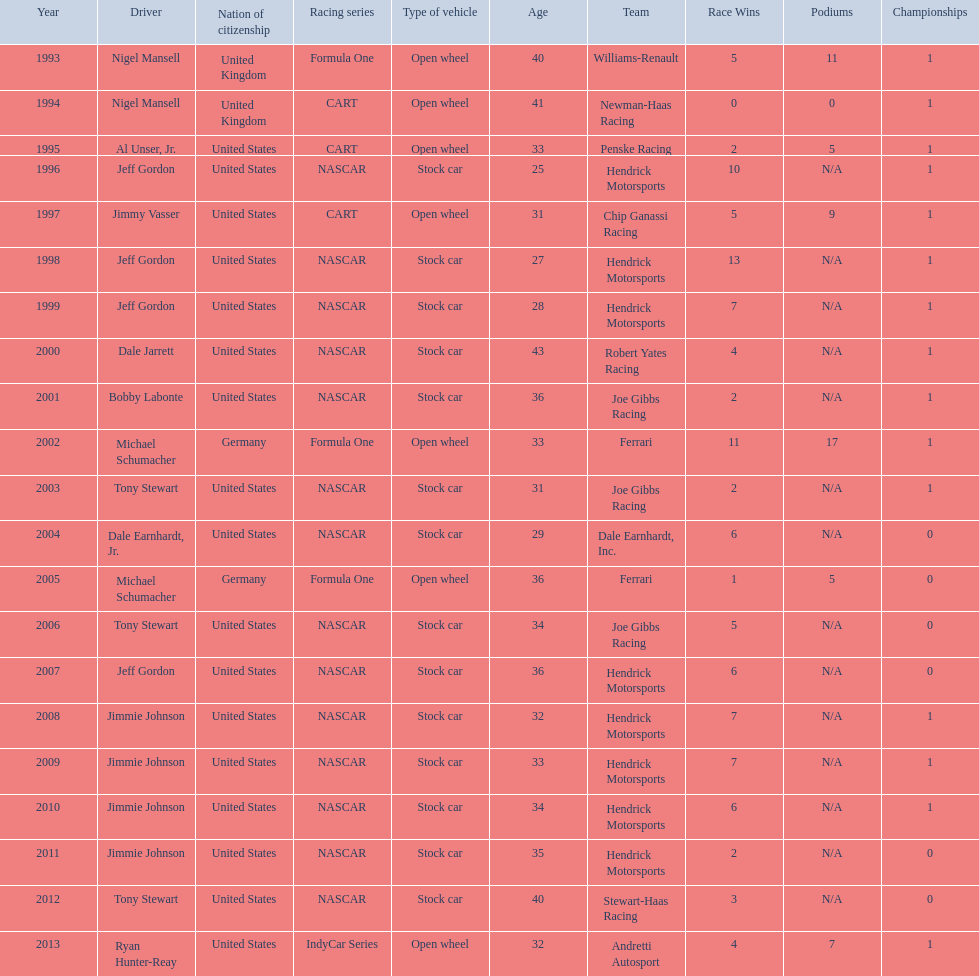Besides nascar, what other racing series have espy-winning drivers come from? Formula One, CART, IndyCar Series. 